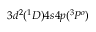<formula> <loc_0><loc_0><loc_500><loc_500>3 d ^ { 2 } ( ^ { 1 } D ) 4 s 4 p ( ^ { 3 } P ^ { o } )</formula> 